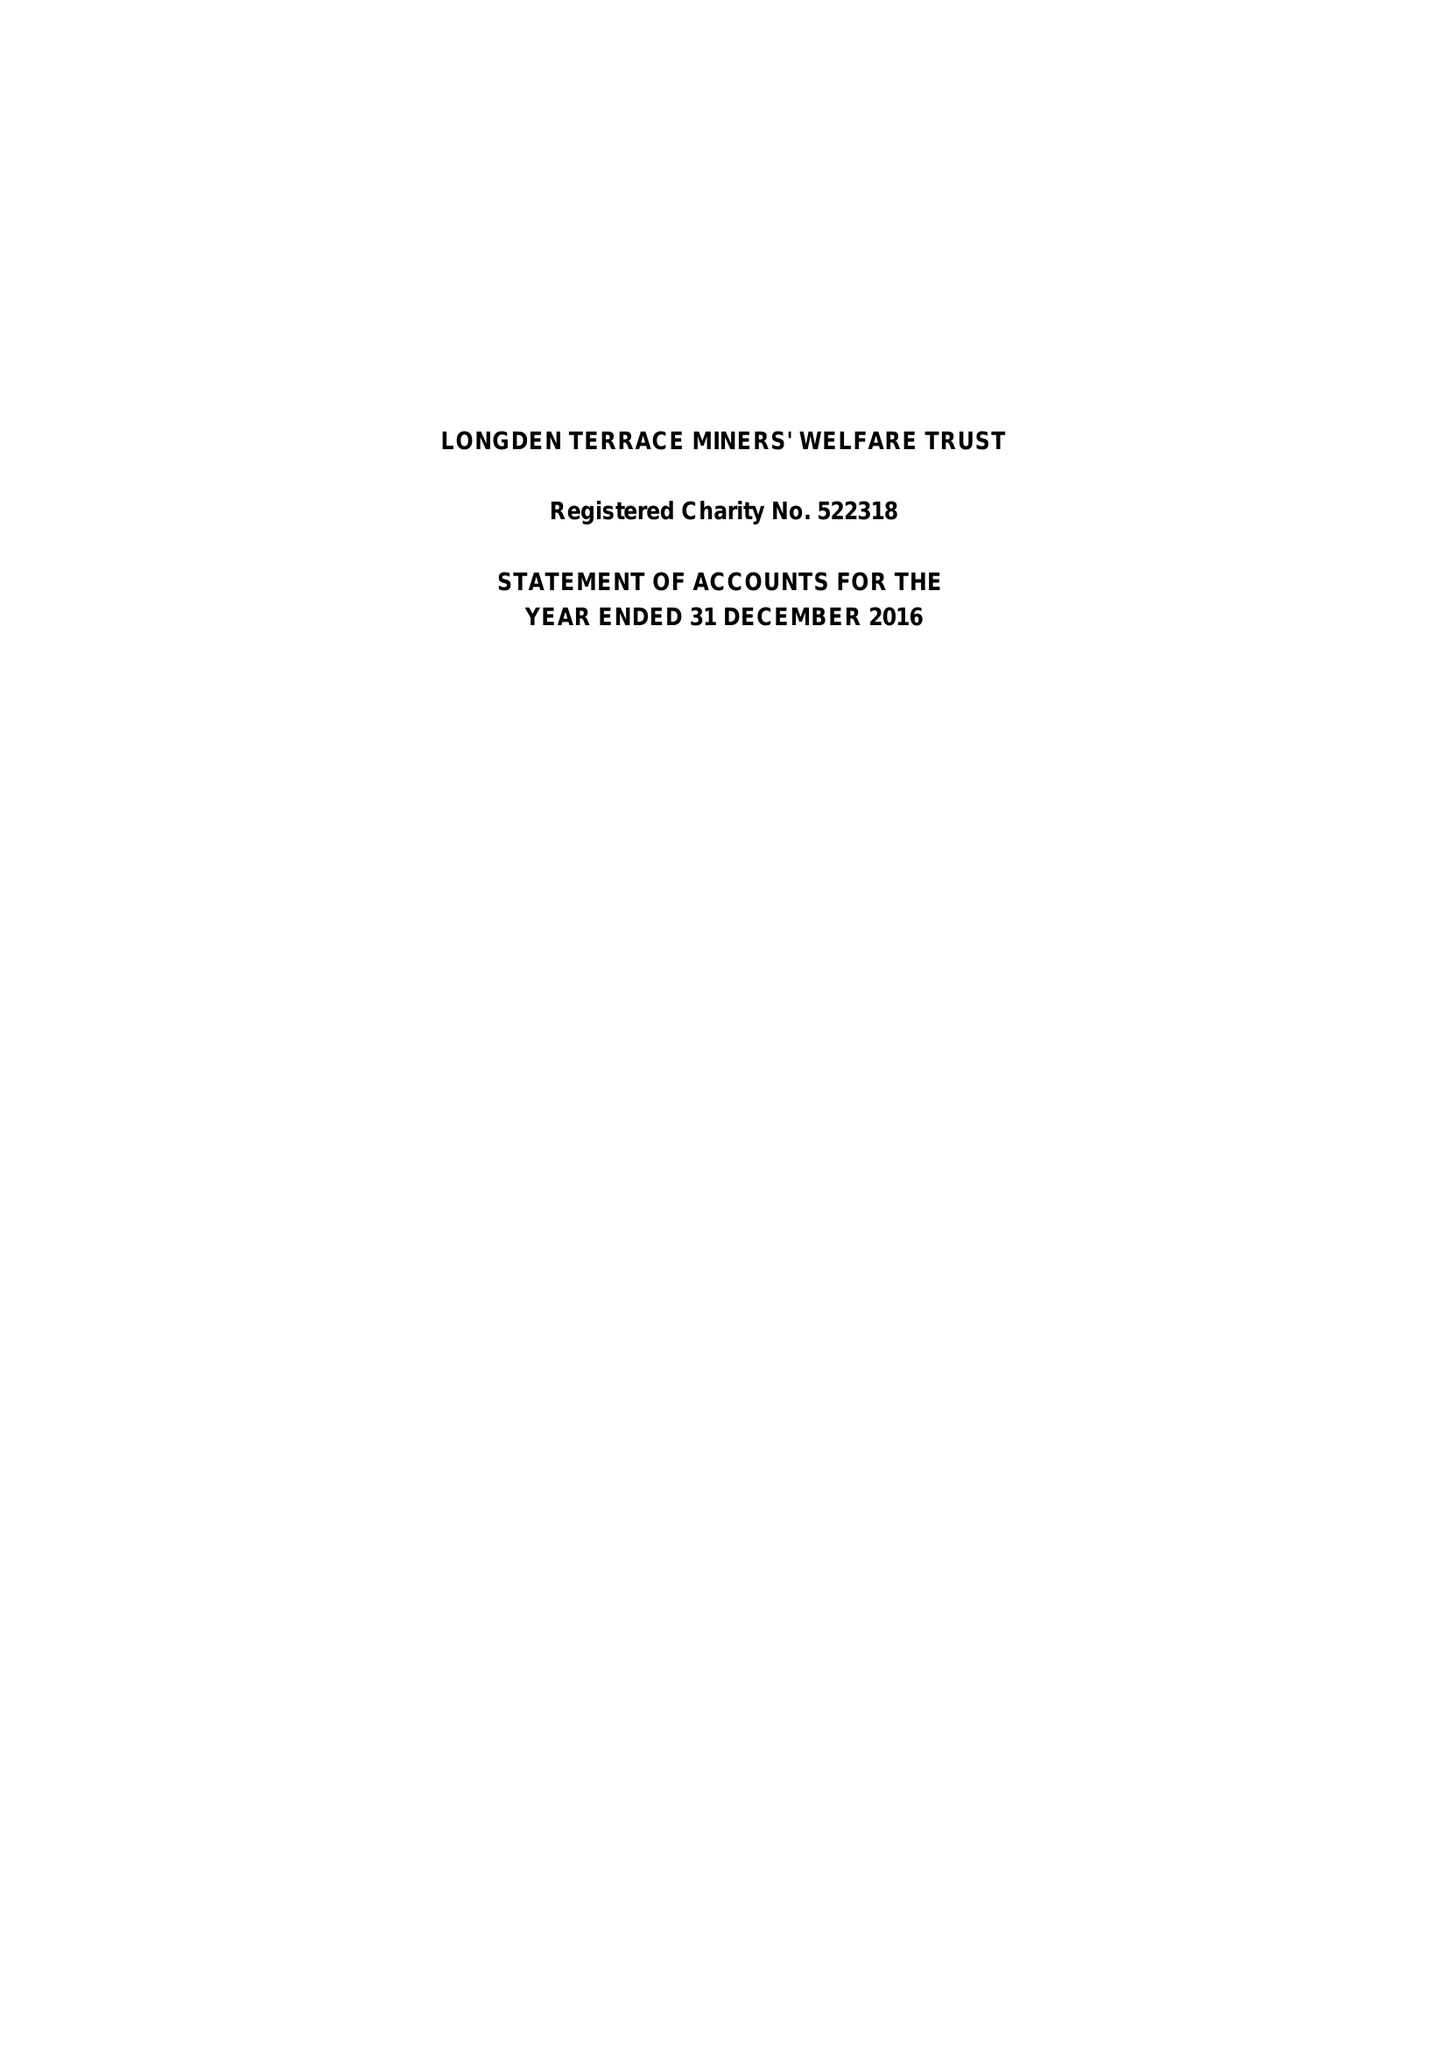What is the value for the charity_name?
Answer the question using a single word or phrase. Longden Terrace Miners' Welfare Trust 